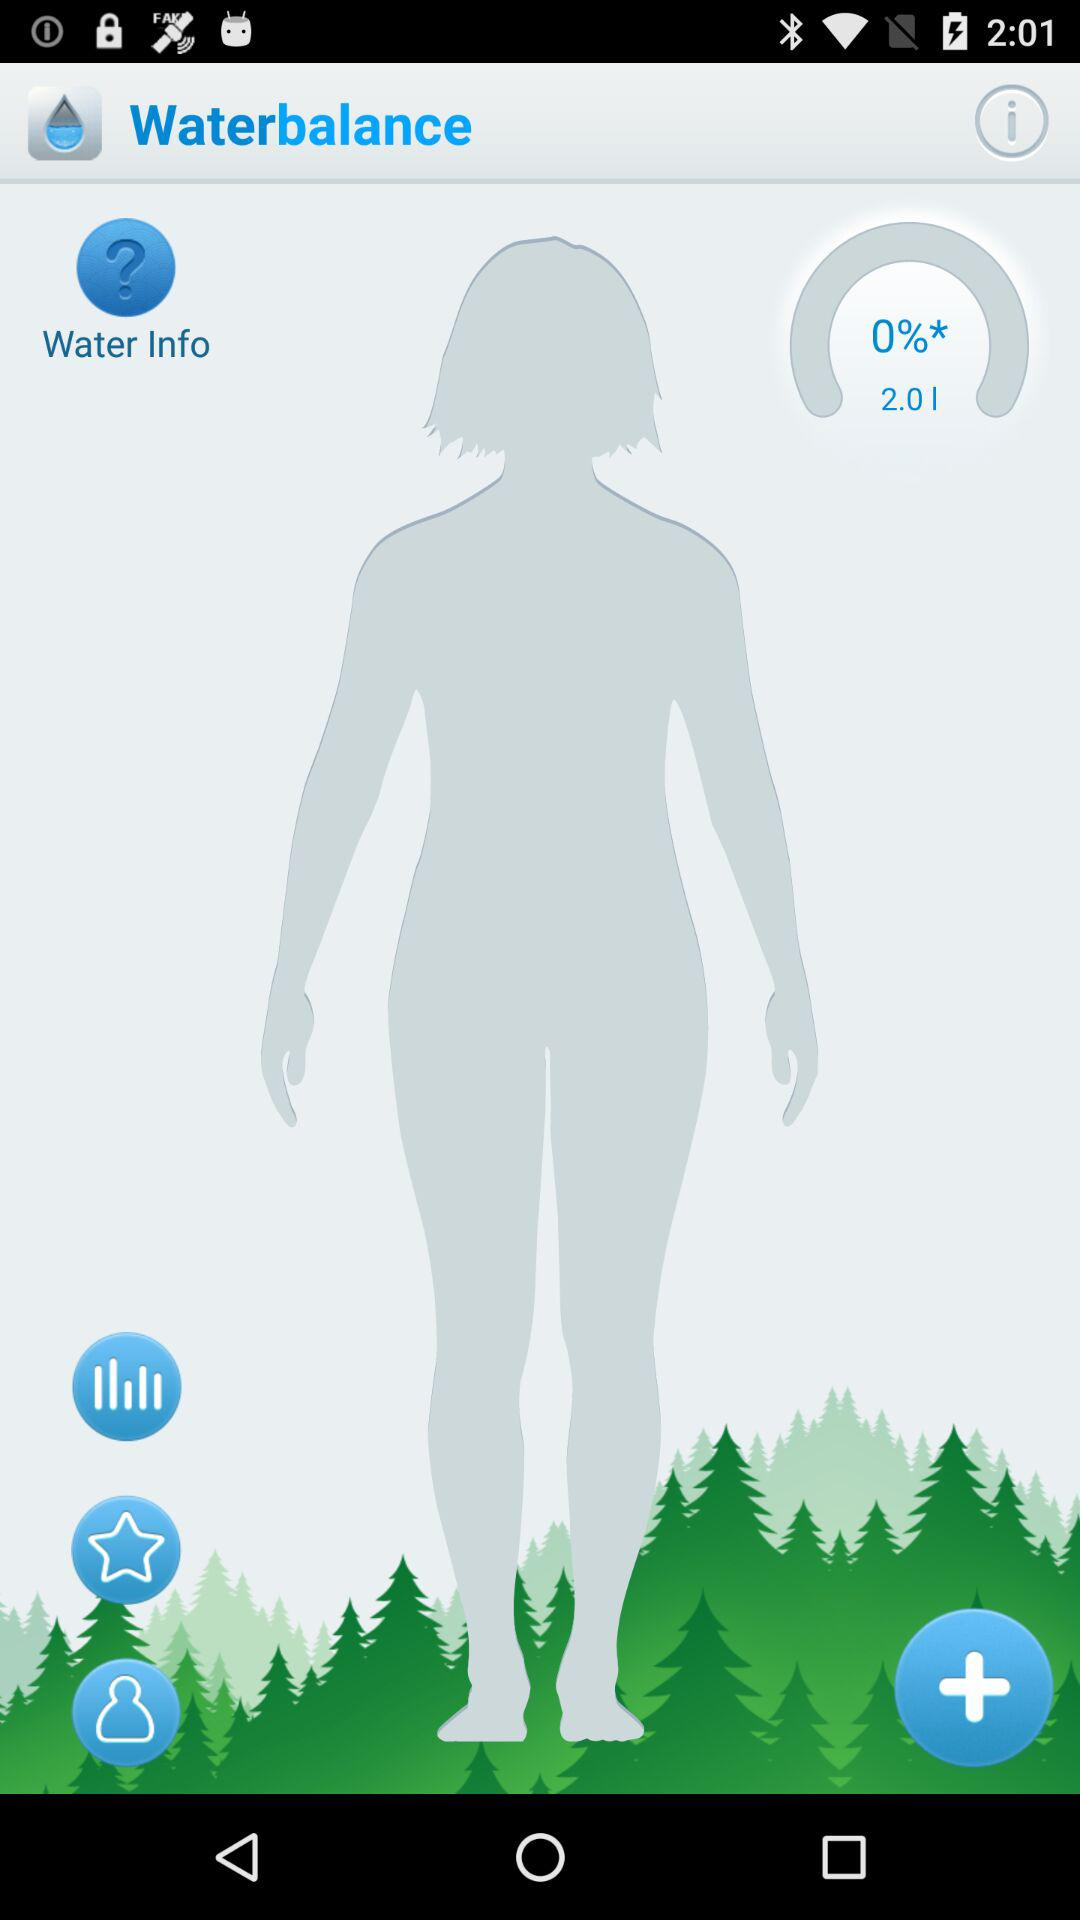What is the application name? The application name is "Waterbalance". 